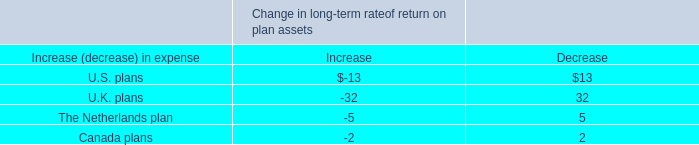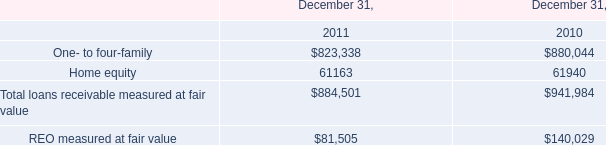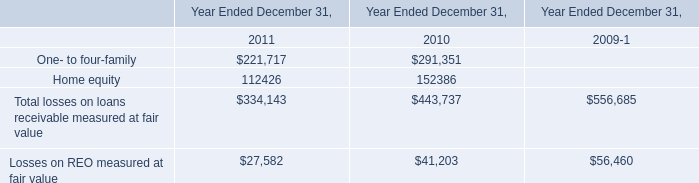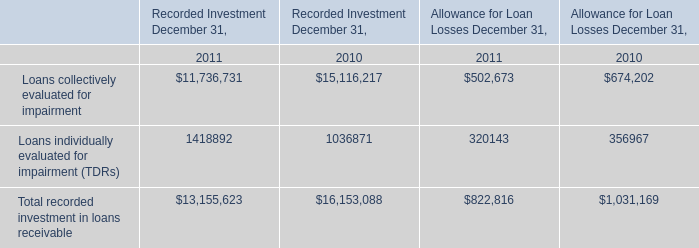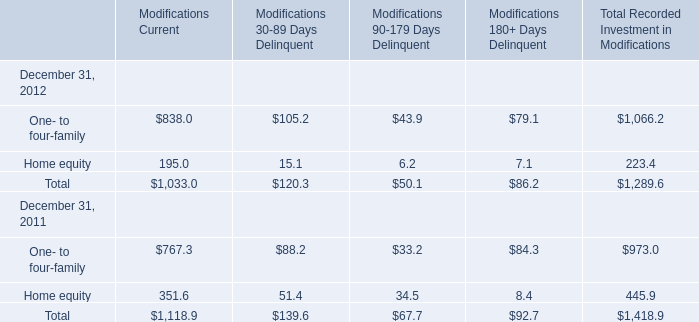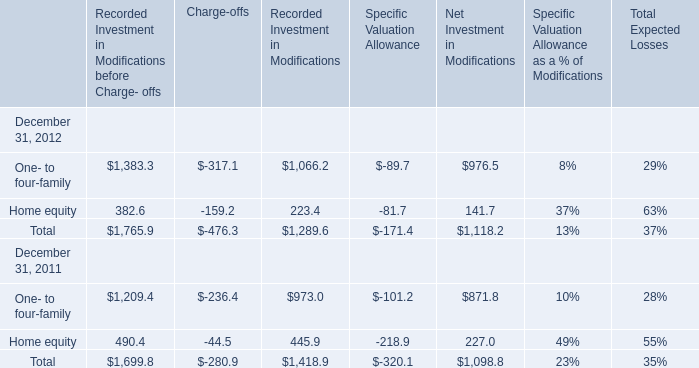What's the current growth rate of One- to four-family's Modifications Current? 
Computations: ((838 - 767.3) / 767.3)
Answer: 0.09214. 